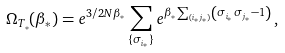Convert formula to latex. <formula><loc_0><loc_0><loc_500><loc_500>\Omega _ { T _ { * } } ( \beta _ { * } ) = e ^ { 3 / 2 N \beta _ { * } } \sum _ { \{ \sigma _ { i _ { * } } \} } e ^ { \beta _ { * } \sum _ { ( i _ { * } j _ { * } ) } \left ( \sigma _ { i _ { * } } \sigma _ { j _ { * } } - 1 \right ) } \, ,</formula> 